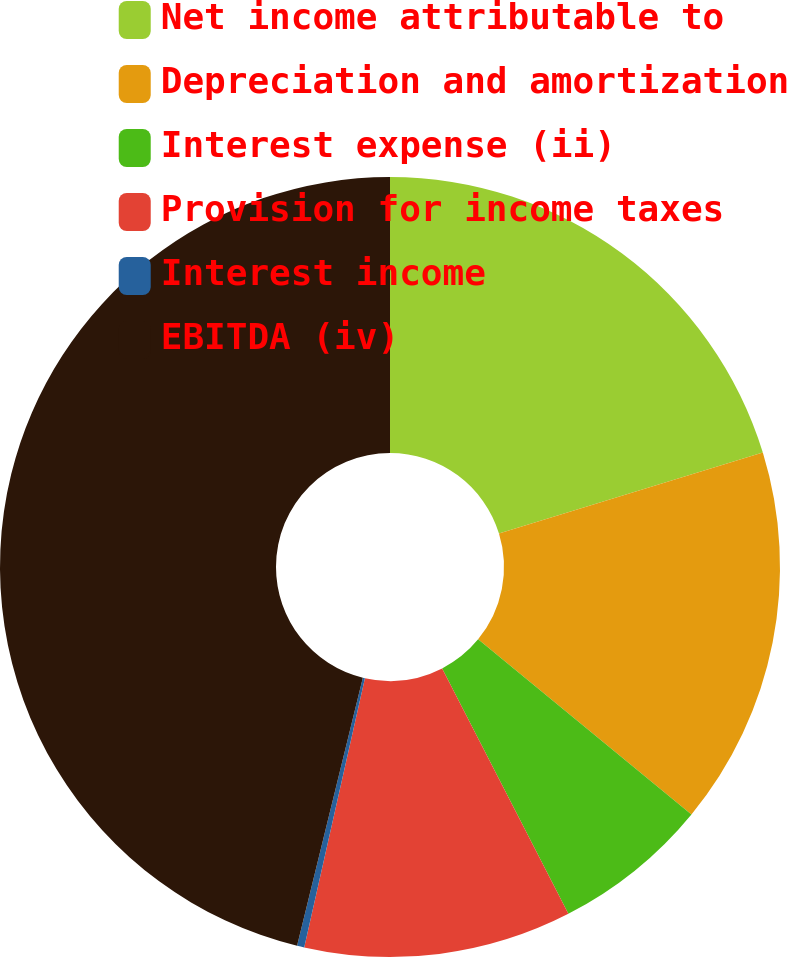Convert chart to OTSL. <chart><loc_0><loc_0><loc_500><loc_500><pie_chart><fcel>Net income attributable to<fcel>Depreciation and amortization<fcel>Interest expense (ii)<fcel>Provision for income taxes<fcel>Interest income<fcel>EBITDA (iv)<nl><fcel>20.26%<fcel>15.68%<fcel>6.5%<fcel>11.09%<fcel>0.3%<fcel>46.17%<nl></chart> 